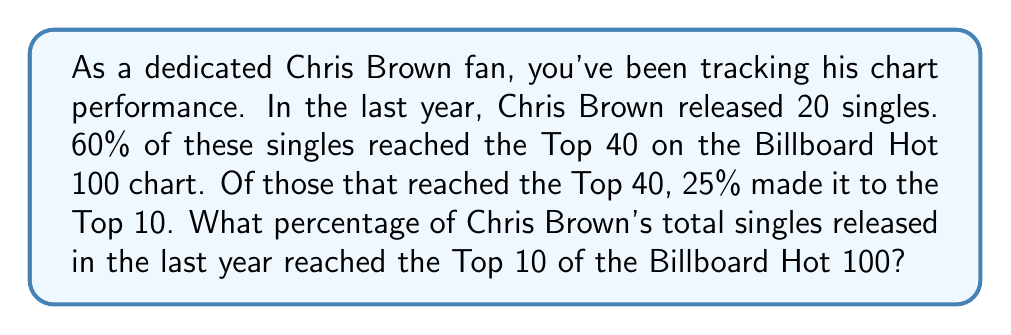Can you answer this question? Let's break this down step by step:

1. Total number of singles released: 20

2. Number of singles that reached the Top 40:
   $60\% \text{ of } 20 = 0.60 \times 20 = 12$ singles

3. Number of singles that reached the Top 10:
   $25\% \text{ of Top 40 singles } = 0.25 \times 12 = 3$ singles

4. To find the percentage of total singles that reached the Top 10:
   $$\text{Percentage} = \frac{\text{Number of Top 10 singles}}{\text{Total number of singles}} \times 100\%$$
   
   $$= \frac{3}{20} \times 100\%$$
   
   $$= 0.15 \times 100\%$$
   
   $$= 15\%$$

Therefore, 15% of Chris Brown's total singles released in the last year reached the Top 10 of the Billboard Hot 100.
Answer: 15% 